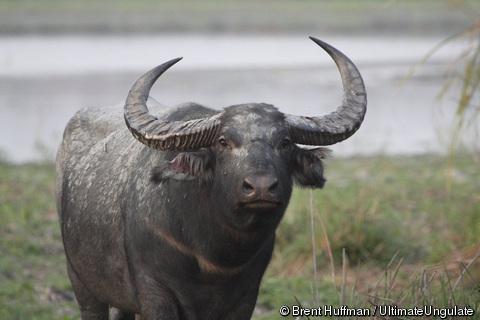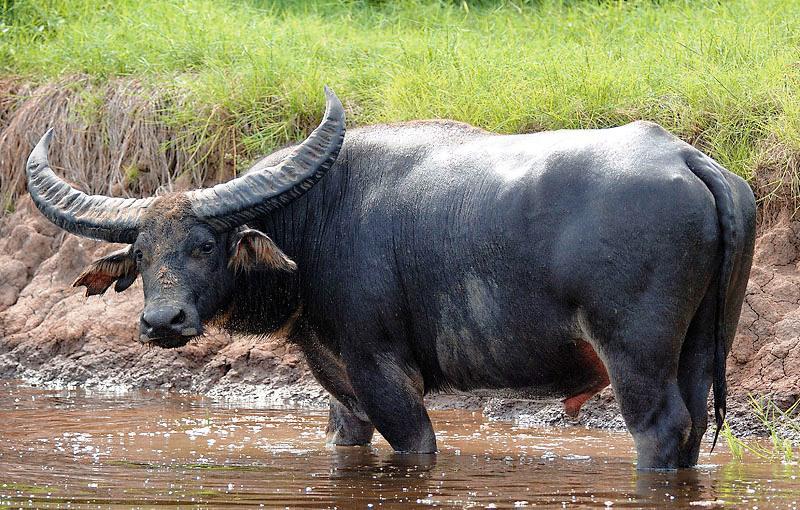The first image is the image on the left, the second image is the image on the right. Evaluate the accuracy of this statement regarding the images: "An image shows exactly one water buffalo, which is standing in muddy water.". Is it true? Answer yes or no. Yes. 